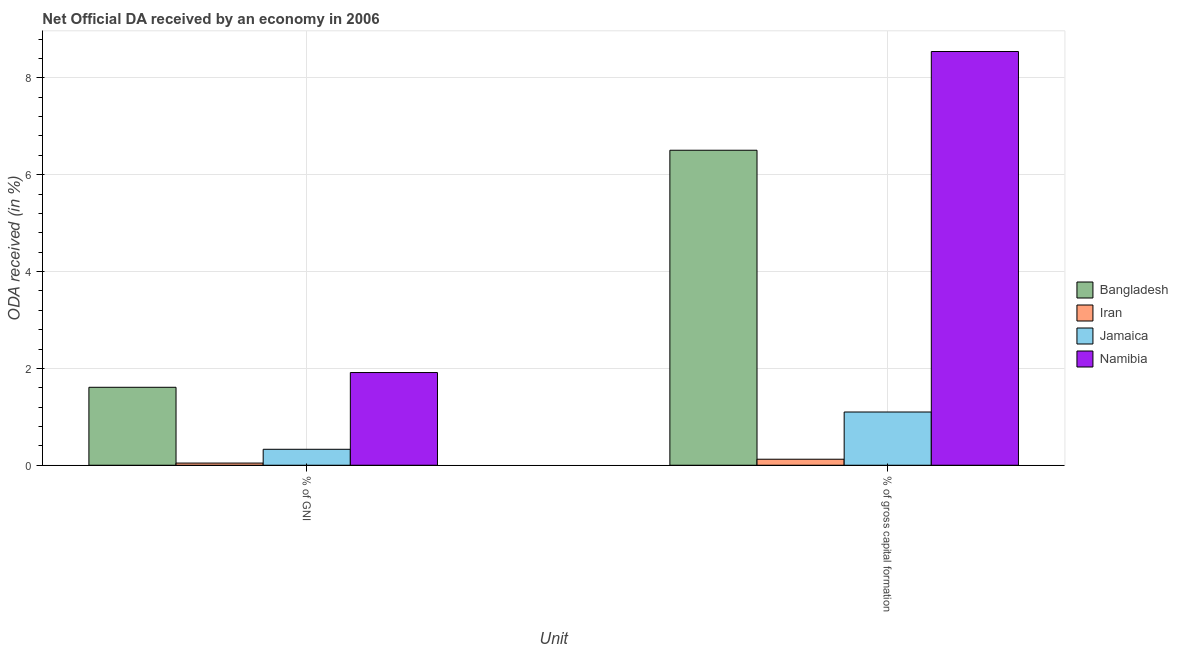How many different coloured bars are there?
Your answer should be very brief. 4. How many groups of bars are there?
Make the answer very short. 2. Are the number of bars per tick equal to the number of legend labels?
Ensure brevity in your answer.  Yes. What is the label of the 2nd group of bars from the left?
Make the answer very short. % of gross capital formation. What is the oda received as percentage of gni in Namibia?
Provide a short and direct response. 1.91. Across all countries, what is the maximum oda received as percentage of gross capital formation?
Make the answer very short. 8.54. Across all countries, what is the minimum oda received as percentage of gni?
Keep it short and to the point. 0.04. In which country was the oda received as percentage of gross capital formation maximum?
Your response must be concise. Namibia. In which country was the oda received as percentage of gni minimum?
Make the answer very short. Iran. What is the total oda received as percentage of gross capital formation in the graph?
Your answer should be very brief. 16.27. What is the difference between the oda received as percentage of gni in Namibia and that in Iran?
Keep it short and to the point. 1.87. What is the difference between the oda received as percentage of gross capital formation in Iran and the oda received as percentage of gni in Bangladesh?
Give a very brief answer. -1.49. What is the average oda received as percentage of gross capital formation per country?
Make the answer very short. 4.07. What is the difference between the oda received as percentage of gross capital formation and oda received as percentage of gni in Jamaica?
Ensure brevity in your answer.  0.77. In how many countries, is the oda received as percentage of gross capital formation greater than 4.4 %?
Give a very brief answer. 2. What is the ratio of the oda received as percentage of gross capital formation in Namibia to that in Jamaica?
Your answer should be compact. 7.77. What does the 2nd bar from the left in % of GNI represents?
Your response must be concise. Iran. What does the 2nd bar from the right in % of GNI represents?
Give a very brief answer. Jamaica. How many bars are there?
Provide a succinct answer. 8. How many countries are there in the graph?
Your response must be concise. 4. What is the difference between two consecutive major ticks on the Y-axis?
Your answer should be very brief. 2. Are the values on the major ticks of Y-axis written in scientific E-notation?
Your answer should be compact. No. Where does the legend appear in the graph?
Give a very brief answer. Center right. What is the title of the graph?
Keep it short and to the point. Net Official DA received by an economy in 2006. Does "Nepal" appear as one of the legend labels in the graph?
Make the answer very short. No. What is the label or title of the X-axis?
Make the answer very short. Unit. What is the label or title of the Y-axis?
Offer a terse response. ODA received (in %). What is the ODA received (in %) in Bangladesh in % of GNI?
Give a very brief answer. 1.61. What is the ODA received (in %) of Iran in % of GNI?
Give a very brief answer. 0.04. What is the ODA received (in %) of Jamaica in % of GNI?
Your answer should be compact. 0.33. What is the ODA received (in %) of Namibia in % of GNI?
Your answer should be very brief. 1.91. What is the ODA received (in %) in Bangladesh in % of gross capital formation?
Give a very brief answer. 6.5. What is the ODA received (in %) in Iran in % of gross capital formation?
Offer a very short reply. 0.12. What is the ODA received (in %) of Jamaica in % of gross capital formation?
Offer a terse response. 1.1. What is the ODA received (in %) of Namibia in % of gross capital formation?
Your response must be concise. 8.54. Across all Unit, what is the maximum ODA received (in %) of Bangladesh?
Ensure brevity in your answer.  6.5. Across all Unit, what is the maximum ODA received (in %) in Iran?
Make the answer very short. 0.12. Across all Unit, what is the maximum ODA received (in %) of Jamaica?
Make the answer very short. 1.1. Across all Unit, what is the maximum ODA received (in %) in Namibia?
Your answer should be compact. 8.54. Across all Unit, what is the minimum ODA received (in %) in Bangladesh?
Offer a terse response. 1.61. Across all Unit, what is the minimum ODA received (in %) in Iran?
Offer a very short reply. 0.04. Across all Unit, what is the minimum ODA received (in %) of Jamaica?
Give a very brief answer. 0.33. Across all Unit, what is the minimum ODA received (in %) in Namibia?
Keep it short and to the point. 1.91. What is the total ODA received (in %) in Bangladesh in the graph?
Give a very brief answer. 8.11. What is the total ODA received (in %) of Iran in the graph?
Provide a succinct answer. 0.17. What is the total ODA received (in %) of Jamaica in the graph?
Your answer should be very brief. 1.43. What is the total ODA received (in %) of Namibia in the graph?
Your answer should be compact. 10.46. What is the difference between the ODA received (in %) in Bangladesh in % of GNI and that in % of gross capital formation?
Your response must be concise. -4.89. What is the difference between the ODA received (in %) of Iran in % of GNI and that in % of gross capital formation?
Ensure brevity in your answer.  -0.08. What is the difference between the ODA received (in %) in Jamaica in % of GNI and that in % of gross capital formation?
Offer a very short reply. -0.77. What is the difference between the ODA received (in %) of Namibia in % of GNI and that in % of gross capital formation?
Keep it short and to the point. -6.63. What is the difference between the ODA received (in %) in Bangladesh in % of GNI and the ODA received (in %) in Iran in % of gross capital formation?
Keep it short and to the point. 1.49. What is the difference between the ODA received (in %) of Bangladesh in % of GNI and the ODA received (in %) of Jamaica in % of gross capital formation?
Give a very brief answer. 0.51. What is the difference between the ODA received (in %) of Bangladesh in % of GNI and the ODA received (in %) of Namibia in % of gross capital formation?
Offer a terse response. -6.93. What is the difference between the ODA received (in %) of Iran in % of GNI and the ODA received (in %) of Jamaica in % of gross capital formation?
Ensure brevity in your answer.  -1.05. What is the difference between the ODA received (in %) of Iran in % of GNI and the ODA received (in %) of Namibia in % of gross capital formation?
Ensure brevity in your answer.  -8.5. What is the difference between the ODA received (in %) of Jamaica in % of GNI and the ODA received (in %) of Namibia in % of gross capital formation?
Ensure brevity in your answer.  -8.21. What is the average ODA received (in %) of Bangladesh per Unit?
Give a very brief answer. 4.06. What is the average ODA received (in %) of Iran per Unit?
Provide a short and direct response. 0.08. What is the average ODA received (in %) of Jamaica per Unit?
Provide a succinct answer. 0.71. What is the average ODA received (in %) in Namibia per Unit?
Offer a terse response. 5.23. What is the difference between the ODA received (in %) of Bangladesh and ODA received (in %) of Iran in % of GNI?
Ensure brevity in your answer.  1.56. What is the difference between the ODA received (in %) in Bangladesh and ODA received (in %) in Jamaica in % of GNI?
Ensure brevity in your answer.  1.28. What is the difference between the ODA received (in %) of Bangladesh and ODA received (in %) of Namibia in % of GNI?
Provide a short and direct response. -0.3. What is the difference between the ODA received (in %) of Iran and ODA received (in %) of Jamaica in % of GNI?
Your answer should be very brief. -0.28. What is the difference between the ODA received (in %) in Iran and ODA received (in %) in Namibia in % of GNI?
Provide a short and direct response. -1.87. What is the difference between the ODA received (in %) of Jamaica and ODA received (in %) of Namibia in % of GNI?
Give a very brief answer. -1.58. What is the difference between the ODA received (in %) of Bangladesh and ODA received (in %) of Iran in % of gross capital formation?
Ensure brevity in your answer.  6.38. What is the difference between the ODA received (in %) in Bangladesh and ODA received (in %) in Jamaica in % of gross capital formation?
Give a very brief answer. 5.4. What is the difference between the ODA received (in %) of Bangladesh and ODA received (in %) of Namibia in % of gross capital formation?
Your response must be concise. -2.04. What is the difference between the ODA received (in %) of Iran and ODA received (in %) of Jamaica in % of gross capital formation?
Give a very brief answer. -0.97. What is the difference between the ODA received (in %) in Iran and ODA received (in %) in Namibia in % of gross capital formation?
Offer a terse response. -8.42. What is the difference between the ODA received (in %) in Jamaica and ODA received (in %) in Namibia in % of gross capital formation?
Provide a succinct answer. -7.44. What is the ratio of the ODA received (in %) in Bangladesh in % of GNI to that in % of gross capital formation?
Provide a short and direct response. 0.25. What is the ratio of the ODA received (in %) in Iran in % of GNI to that in % of gross capital formation?
Keep it short and to the point. 0.36. What is the ratio of the ODA received (in %) in Jamaica in % of GNI to that in % of gross capital formation?
Your answer should be very brief. 0.3. What is the ratio of the ODA received (in %) of Namibia in % of GNI to that in % of gross capital formation?
Give a very brief answer. 0.22. What is the difference between the highest and the second highest ODA received (in %) in Bangladesh?
Your answer should be compact. 4.89. What is the difference between the highest and the second highest ODA received (in %) in Iran?
Offer a terse response. 0.08. What is the difference between the highest and the second highest ODA received (in %) in Jamaica?
Ensure brevity in your answer.  0.77. What is the difference between the highest and the second highest ODA received (in %) in Namibia?
Offer a terse response. 6.63. What is the difference between the highest and the lowest ODA received (in %) of Bangladesh?
Offer a very short reply. 4.89. What is the difference between the highest and the lowest ODA received (in %) in Iran?
Keep it short and to the point. 0.08. What is the difference between the highest and the lowest ODA received (in %) of Jamaica?
Give a very brief answer. 0.77. What is the difference between the highest and the lowest ODA received (in %) of Namibia?
Give a very brief answer. 6.63. 